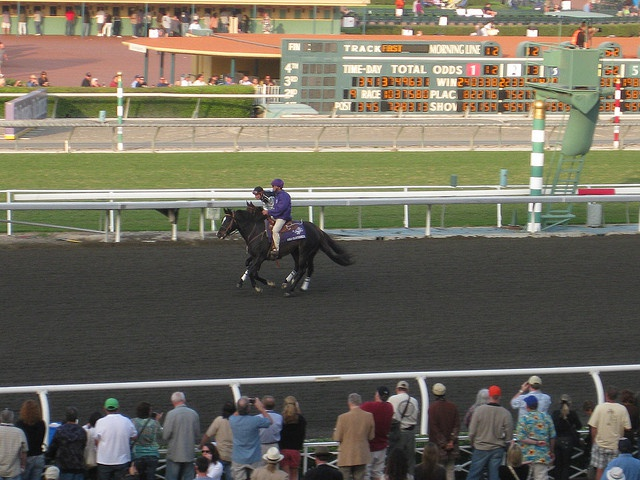Describe the objects in this image and their specific colors. I can see people in khaki, black, gray, darkgray, and tan tones, horse in khaki, black, gray, and darkgray tones, people in khaki, gray, black, and darkblue tones, people in khaki, gray, black, and blue tones, and people in khaki, gray, black, and maroon tones in this image. 